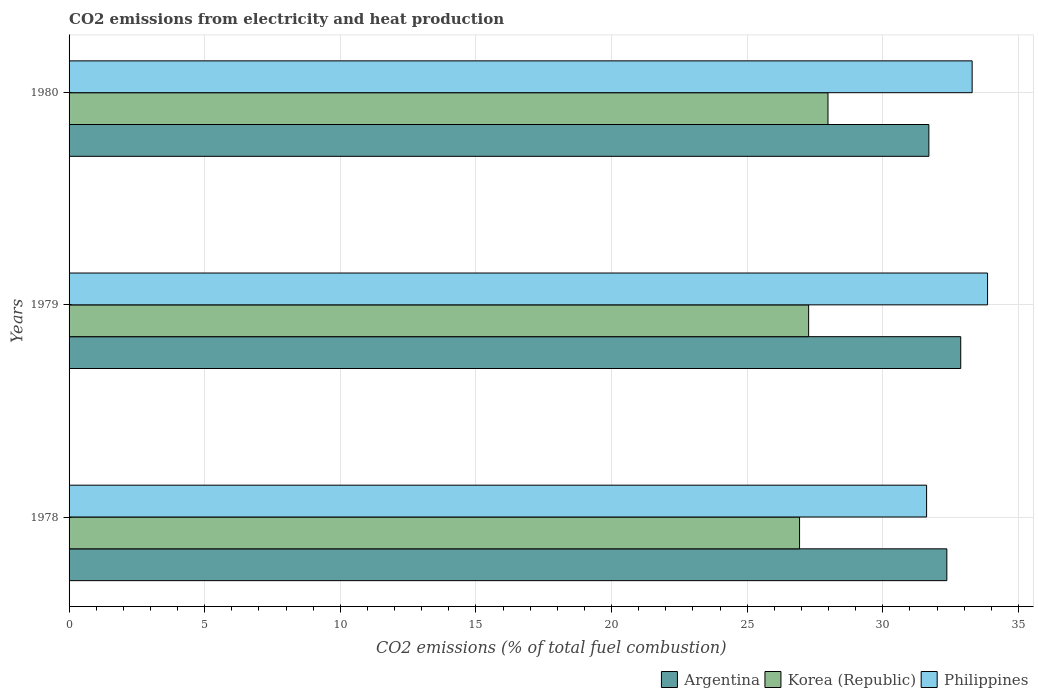How many different coloured bars are there?
Make the answer very short. 3. Are the number of bars per tick equal to the number of legend labels?
Your answer should be compact. Yes. How many bars are there on the 2nd tick from the top?
Your response must be concise. 3. What is the amount of CO2 emitted in Argentina in 1980?
Offer a terse response. 31.7. Across all years, what is the maximum amount of CO2 emitted in Korea (Republic)?
Offer a very short reply. 27.98. Across all years, what is the minimum amount of CO2 emitted in Argentina?
Provide a succinct answer. 31.7. In which year was the amount of CO2 emitted in Argentina maximum?
Your response must be concise. 1979. In which year was the amount of CO2 emitted in Argentina minimum?
Make the answer very short. 1980. What is the total amount of CO2 emitted in Philippines in the graph?
Ensure brevity in your answer.  98.77. What is the difference between the amount of CO2 emitted in Argentina in 1978 and that in 1979?
Offer a very short reply. -0.51. What is the difference between the amount of CO2 emitted in Argentina in 1980 and the amount of CO2 emitted in Philippines in 1978?
Offer a very short reply. 0.08. What is the average amount of CO2 emitted in Korea (Republic) per year?
Provide a short and direct response. 27.39. In the year 1978, what is the difference between the amount of CO2 emitted in Argentina and amount of CO2 emitted in Philippines?
Provide a short and direct response. 0.75. In how many years, is the amount of CO2 emitted in Philippines greater than 11 %?
Ensure brevity in your answer.  3. What is the ratio of the amount of CO2 emitted in Philippines in 1978 to that in 1979?
Give a very brief answer. 0.93. What is the difference between the highest and the second highest amount of CO2 emitted in Argentina?
Keep it short and to the point. 0.51. What is the difference between the highest and the lowest amount of CO2 emitted in Philippines?
Provide a short and direct response. 2.25. Is the sum of the amount of CO2 emitted in Korea (Republic) in 1979 and 1980 greater than the maximum amount of CO2 emitted in Philippines across all years?
Keep it short and to the point. Yes. Is it the case that in every year, the sum of the amount of CO2 emitted in Philippines and amount of CO2 emitted in Korea (Republic) is greater than the amount of CO2 emitted in Argentina?
Offer a terse response. Yes. How many years are there in the graph?
Your answer should be very brief. 3. What is the difference between two consecutive major ticks on the X-axis?
Give a very brief answer. 5. Are the values on the major ticks of X-axis written in scientific E-notation?
Keep it short and to the point. No. Does the graph contain grids?
Your answer should be very brief. Yes. How are the legend labels stacked?
Offer a terse response. Horizontal. What is the title of the graph?
Keep it short and to the point. CO2 emissions from electricity and heat production. Does "Zambia" appear as one of the legend labels in the graph?
Offer a very short reply. No. What is the label or title of the X-axis?
Offer a very short reply. CO2 emissions (% of total fuel combustion). What is the label or title of the Y-axis?
Offer a terse response. Years. What is the CO2 emissions (% of total fuel combustion) in Argentina in 1978?
Your answer should be very brief. 32.36. What is the CO2 emissions (% of total fuel combustion) in Korea (Republic) in 1978?
Give a very brief answer. 26.93. What is the CO2 emissions (% of total fuel combustion) of Philippines in 1978?
Provide a short and direct response. 31.61. What is the CO2 emissions (% of total fuel combustion) of Argentina in 1979?
Your answer should be compact. 32.87. What is the CO2 emissions (% of total fuel combustion) in Korea (Republic) in 1979?
Give a very brief answer. 27.27. What is the CO2 emissions (% of total fuel combustion) in Philippines in 1979?
Offer a very short reply. 33.86. What is the CO2 emissions (% of total fuel combustion) in Argentina in 1980?
Ensure brevity in your answer.  31.7. What is the CO2 emissions (% of total fuel combustion) in Korea (Republic) in 1980?
Provide a short and direct response. 27.98. What is the CO2 emissions (% of total fuel combustion) of Philippines in 1980?
Make the answer very short. 33.29. Across all years, what is the maximum CO2 emissions (% of total fuel combustion) of Argentina?
Keep it short and to the point. 32.87. Across all years, what is the maximum CO2 emissions (% of total fuel combustion) in Korea (Republic)?
Your answer should be compact. 27.98. Across all years, what is the maximum CO2 emissions (% of total fuel combustion) of Philippines?
Give a very brief answer. 33.86. Across all years, what is the minimum CO2 emissions (% of total fuel combustion) of Argentina?
Provide a succinct answer. 31.7. Across all years, what is the minimum CO2 emissions (% of total fuel combustion) in Korea (Republic)?
Offer a very short reply. 26.93. Across all years, what is the minimum CO2 emissions (% of total fuel combustion) of Philippines?
Your answer should be compact. 31.61. What is the total CO2 emissions (% of total fuel combustion) in Argentina in the graph?
Ensure brevity in your answer.  96.93. What is the total CO2 emissions (% of total fuel combustion) in Korea (Republic) in the graph?
Your answer should be compact. 82.18. What is the total CO2 emissions (% of total fuel combustion) of Philippines in the graph?
Your answer should be very brief. 98.77. What is the difference between the CO2 emissions (% of total fuel combustion) of Argentina in 1978 and that in 1979?
Provide a short and direct response. -0.51. What is the difference between the CO2 emissions (% of total fuel combustion) of Korea (Republic) in 1978 and that in 1979?
Offer a very short reply. -0.33. What is the difference between the CO2 emissions (% of total fuel combustion) of Philippines in 1978 and that in 1979?
Give a very brief answer. -2.25. What is the difference between the CO2 emissions (% of total fuel combustion) in Argentina in 1978 and that in 1980?
Keep it short and to the point. 0.66. What is the difference between the CO2 emissions (% of total fuel combustion) in Korea (Republic) in 1978 and that in 1980?
Give a very brief answer. -1.05. What is the difference between the CO2 emissions (% of total fuel combustion) in Philippines in 1978 and that in 1980?
Your answer should be very brief. -1.68. What is the difference between the CO2 emissions (% of total fuel combustion) in Argentina in 1979 and that in 1980?
Ensure brevity in your answer.  1.17. What is the difference between the CO2 emissions (% of total fuel combustion) in Korea (Republic) in 1979 and that in 1980?
Provide a short and direct response. -0.71. What is the difference between the CO2 emissions (% of total fuel combustion) of Philippines in 1979 and that in 1980?
Keep it short and to the point. 0.57. What is the difference between the CO2 emissions (% of total fuel combustion) in Argentina in 1978 and the CO2 emissions (% of total fuel combustion) in Korea (Republic) in 1979?
Offer a very short reply. 5.09. What is the difference between the CO2 emissions (% of total fuel combustion) of Argentina in 1978 and the CO2 emissions (% of total fuel combustion) of Philippines in 1979?
Your response must be concise. -1.5. What is the difference between the CO2 emissions (% of total fuel combustion) of Korea (Republic) in 1978 and the CO2 emissions (% of total fuel combustion) of Philippines in 1979?
Your answer should be very brief. -6.93. What is the difference between the CO2 emissions (% of total fuel combustion) in Argentina in 1978 and the CO2 emissions (% of total fuel combustion) in Korea (Republic) in 1980?
Offer a terse response. 4.38. What is the difference between the CO2 emissions (% of total fuel combustion) of Argentina in 1978 and the CO2 emissions (% of total fuel combustion) of Philippines in 1980?
Your response must be concise. -0.93. What is the difference between the CO2 emissions (% of total fuel combustion) of Korea (Republic) in 1978 and the CO2 emissions (% of total fuel combustion) of Philippines in 1980?
Your answer should be very brief. -6.36. What is the difference between the CO2 emissions (% of total fuel combustion) of Argentina in 1979 and the CO2 emissions (% of total fuel combustion) of Korea (Republic) in 1980?
Give a very brief answer. 4.89. What is the difference between the CO2 emissions (% of total fuel combustion) of Argentina in 1979 and the CO2 emissions (% of total fuel combustion) of Philippines in 1980?
Your answer should be very brief. -0.42. What is the difference between the CO2 emissions (% of total fuel combustion) of Korea (Republic) in 1979 and the CO2 emissions (% of total fuel combustion) of Philippines in 1980?
Your answer should be very brief. -6.03. What is the average CO2 emissions (% of total fuel combustion) of Argentina per year?
Offer a very short reply. 32.31. What is the average CO2 emissions (% of total fuel combustion) of Korea (Republic) per year?
Offer a very short reply. 27.39. What is the average CO2 emissions (% of total fuel combustion) of Philippines per year?
Your answer should be compact. 32.92. In the year 1978, what is the difference between the CO2 emissions (% of total fuel combustion) in Argentina and CO2 emissions (% of total fuel combustion) in Korea (Republic)?
Make the answer very short. 5.43. In the year 1978, what is the difference between the CO2 emissions (% of total fuel combustion) in Argentina and CO2 emissions (% of total fuel combustion) in Philippines?
Ensure brevity in your answer.  0.75. In the year 1978, what is the difference between the CO2 emissions (% of total fuel combustion) of Korea (Republic) and CO2 emissions (% of total fuel combustion) of Philippines?
Make the answer very short. -4.68. In the year 1979, what is the difference between the CO2 emissions (% of total fuel combustion) of Argentina and CO2 emissions (% of total fuel combustion) of Korea (Republic)?
Make the answer very short. 5.61. In the year 1979, what is the difference between the CO2 emissions (% of total fuel combustion) in Argentina and CO2 emissions (% of total fuel combustion) in Philippines?
Your answer should be very brief. -0.99. In the year 1979, what is the difference between the CO2 emissions (% of total fuel combustion) in Korea (Republic) and CO2 emissions (% of total fuel combustion) in Philippines?
Give a very brief answer. -6.6. In the year 1980, what is the difference between the CO2 emissions (% of total fuel combustion) of Argentina and CO2 emissions (% of total fuel combustion) of Korea (Republic)?
Offer a terse response. 3.72. In the year 1980, what is the difference between the CO2 emissions (% of total fuel combustion) of Argentina and CO2 emissions (% of total fuel combustion) of Philippines?
Offer a terse response. -1.59. In the year 1980, what is the difference between the CO2 emissions (% of total fuel combustion) of Korea (Republic) and CO2 emissions (% of total fuel combustion) of Philippines?
Ensure brevity in your answer.  -5.31. What is the ratio of the CO2 emissions (% of total fuel combustion) of Argentina in 1978 to that in 1979?
Your answer should be compact. 0.98. What is the ratio of the CO2 emissions (% of total fuel combustion) of Philippines in 1978 to that in 1979?
Provide a succinct answer. 0.93. What is the ratio of the CO2 emissions (% of total fuel combustion) in Argentina in 1978 to that in 1980?
Give a very brief answer. 1.02. What is the ratio of the CO2 emissions (% of total fuel combustion) of Korea (Republic) in 1978 to that in 1980?
Make the answer very short. 0.96. What is the ratio of the CO2 emissions (% of total fuel combustion) in Philippines in 1978 to that in 1980?
Give a very brief answer. 0.95. What is the ratio of the CO2 emissions (% of total fuel combustion) in Argentina in 1979 to that in 1980?
Make the answer very short. 1.04. What is the ratio of the CO2 emissions (% of total fuel combustion) in Korea (Republic) in 1979 to that in 1980?
Provide a succinct answer. 0.97. What is the ratio of the CO2 emissions (% of total fuel combustion) of Philippines in 1979 to that in 1980?
Your answer should be compact. 1.02. What is the difference between the highest and the second highest CO2 emissions (% of total fuel combustion) in Argentina?
Provide a succinct answer. 0.51. What is the difference between the highest and the second highest CO2 emissions (% of total fuel combustion) in Korea (Republic)?
Offer a terse response. 0.71. What is the difference between the highest and the second highest CO2 emissions (% of total fuel combustion) of Philippines?
Your answer should be very brief. 0.57. What is the difference between the highest and the lowest CO2 emissions (% of total fuel combustion) of Argentina?
Give a very brief answer. 1.17. What is the difference between the highest and the lowest CO2 emissions (% of total fuel combustion) of Korea (Republic)?
Make the answer very short. 1.05. What is the difference between the highest and the lowest CO2 emissions (% of total fuel combustion) in Philippines?
Keep it short and to the point. 2.25. 